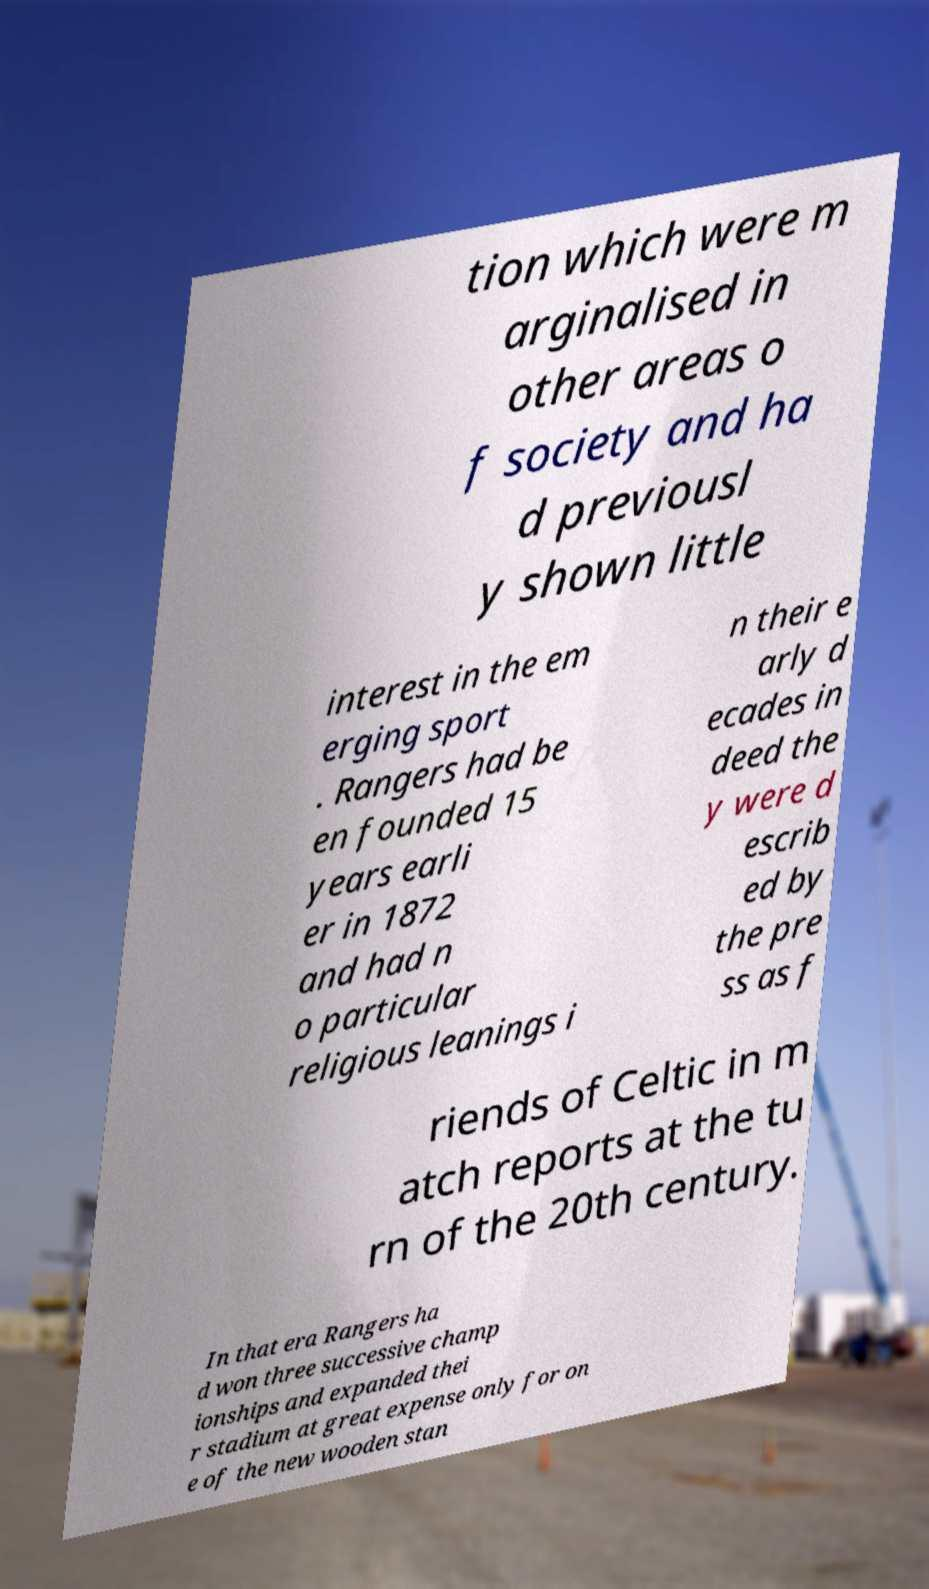There's text embedded in this image that I need extracted. Can you transcribe it verbatim? tion which were m arginalised in other areas o f society and ha d previousl y shown little interest in the em erging sport . Rangers had be en founded 15 years earli er in 1872 and had n o particular religious leanings i n their e arly d ecades in deed the y were d escrib ed by the pre ss as f riends of Celtic in m atch reports at the tu rn of the 20th century. In that era Rangers ha d won three successive champ ionships and expanded thei r stadium at great expense only for on e of the new wooden stan 